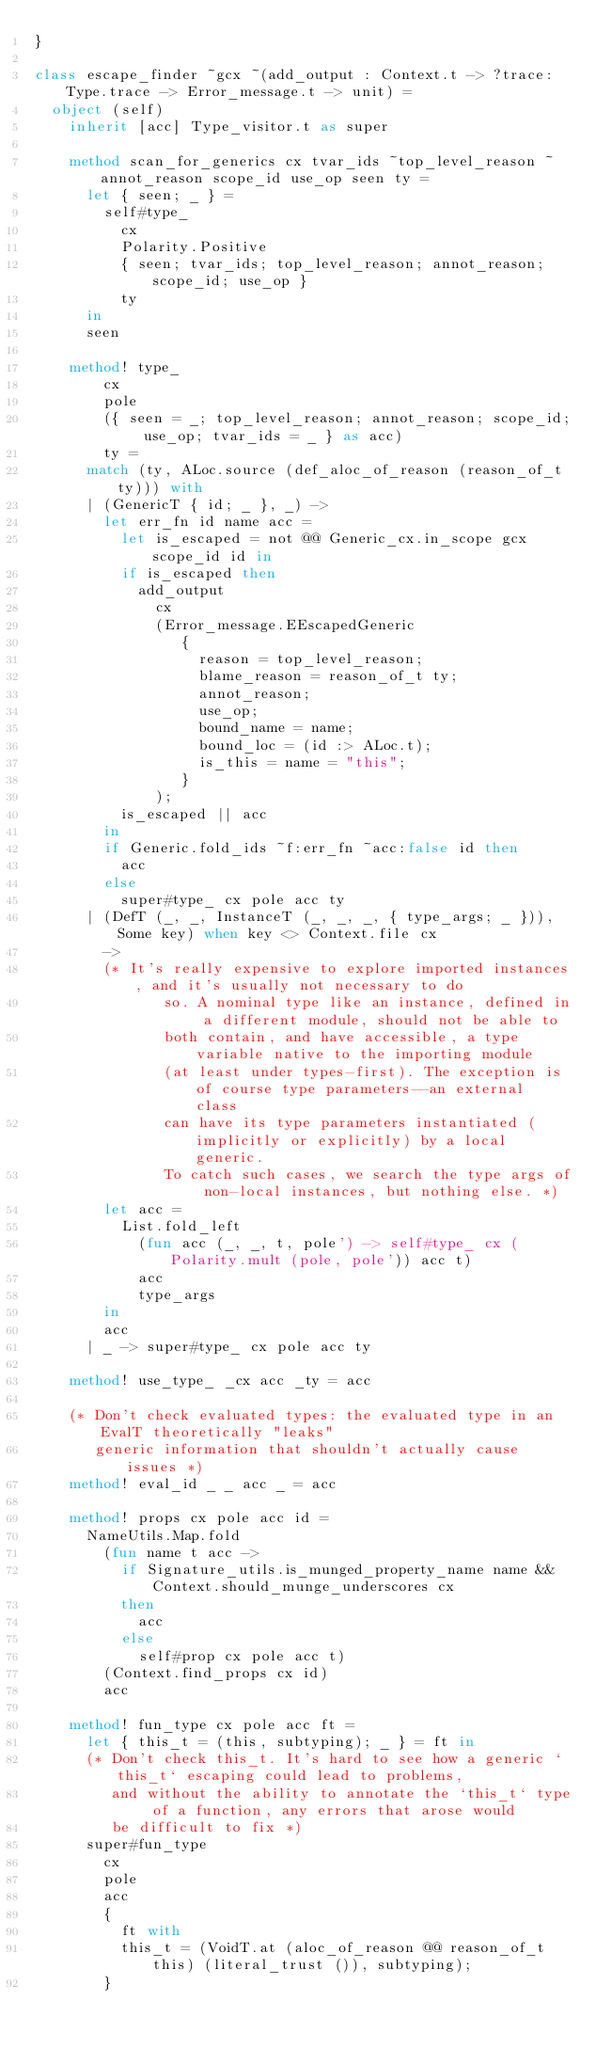Convert code to text. <code><loc_0><loc_0><loc_500><loc_500><_OCaml_>}

class escape_finder ~gcx ~(add_output : Context.t -> ?trace:Type.trace -> Error_message.t -> unit) =
  object (self)
    inherit [acc] Type_visitor.t as super

    method scan_for_generics cx tvar_ids ~top_level_reason ~annot_reason scope_id use_op seen ty =
      let { seen; _ } =
        self#type_
          cx
          Polarity.Positive
          { seen; tvar_ids; top_level_reason; annot_reason; scope_id; use_op }
          ty
      in
      seen

    method! type_
        cx
        pole
        ({ seen = _; top_level_reason; annot_reason; scope_id; use_op; tvar_ids = _ } as acc)
        ty =
      match (ty, ALoc.source (def_aloc_of_reason (reason_of_t ty))) with
      | (GenericT { id; _ }, _) ->
        let err_fn id name acc =
          let is_escaped = not @@ Generic_cx.in_scope gcx scope_id id in
          if is_escaped then
            add_output
              cx
              (Error_message.EEscapedGeneric
                 {
                   reason = top_level_reason;
                   blame_reason = reason_of_t ty;
                   annot_reason;
                   use_op;
                   bound_name = name;
                   bound_loc = (id :> ALoc.t);
                   is_this = name = "this";
                 }
              );
          is_escaped || acc
        in
        if Generic.fold_ids ~f:err_fn ~acc:false id then
          acc
        else
          super#type_ cx pole acc ty
      | (DefT (_, _, InstanceT (_, _, _, { type_args; _ })), Some key) when key <> Context.file cx
        ->
        (* It's really expensive to explore imported instances, and it's usually not necessary to do
               so. A nominal type like an instance, defined in a different module, should not be able to
               both contain, and have accessible, a type variable native to the importing module
               (at least under types-first). The exception is of course type parameters--an external class
               can have its type parameters instantiated (implicitly or explicitly) by a local generic.
               To catch such cases, we search the type args of non-local instances, but nothing else. *)
        let acc =
          List.fold_left
            (fun acc (_, _, t, pole') -> self#type_ cx (Polarity.mult (pole, pole')) acc t)
            acc
            type_args
        in
        acc
      | _ -> super#type_ cx pole acc ty

    method! use_type_ _cx acc _ty = acc

    (* Don't check evaluated types: the evaluated type in an EvalT theoretically "leaks"
       generic information that shouldn't actually cause issues *)
    method! eval_id _ _ acc _ = acc

    method! props cx pole acc id =
      NameUtils.Map.fold
        (fun name t acc ->
          if Signature_utils.is_munged_property_name name && Context.should_munge_underscores cx
          then
            acc
          else
            self#prop cx pole acc t)
        (Context.find_props cx id)
        acc

    method! fun_type cx pole acc ft =
      let { this_t = (this, subtyping); _ } = ft in
      (* Don't check this_t. It's hard to see how a generic `this_t` escaping could lead to problems,
         and without the ability to annotate the `this_t` type of a function, any errors that arose would
         be difficult to fix *)
      super#fun_type
        cx
        pole
        acc
        {
          ft with
          this_t = (VoidT.at (aloc_of_reason @@ reason_of_t this) (literal_trust ()), subtyping);
        }
</code> 